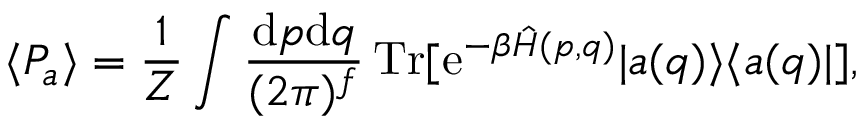Convert formula to latex. <formula><loc_0><loc_0><loc_500><loc_500>\langle { P } _ { a } \rangle = \frac { 1 } { Z } \int \frac { d p d q } { ( 2 \pi ) ^ { f } } \, T r [ e ^ { - \beta \hat { H } ( p , q ) } | a ( q ) \rangle \langle a ( q ) | ] ,</formula> 